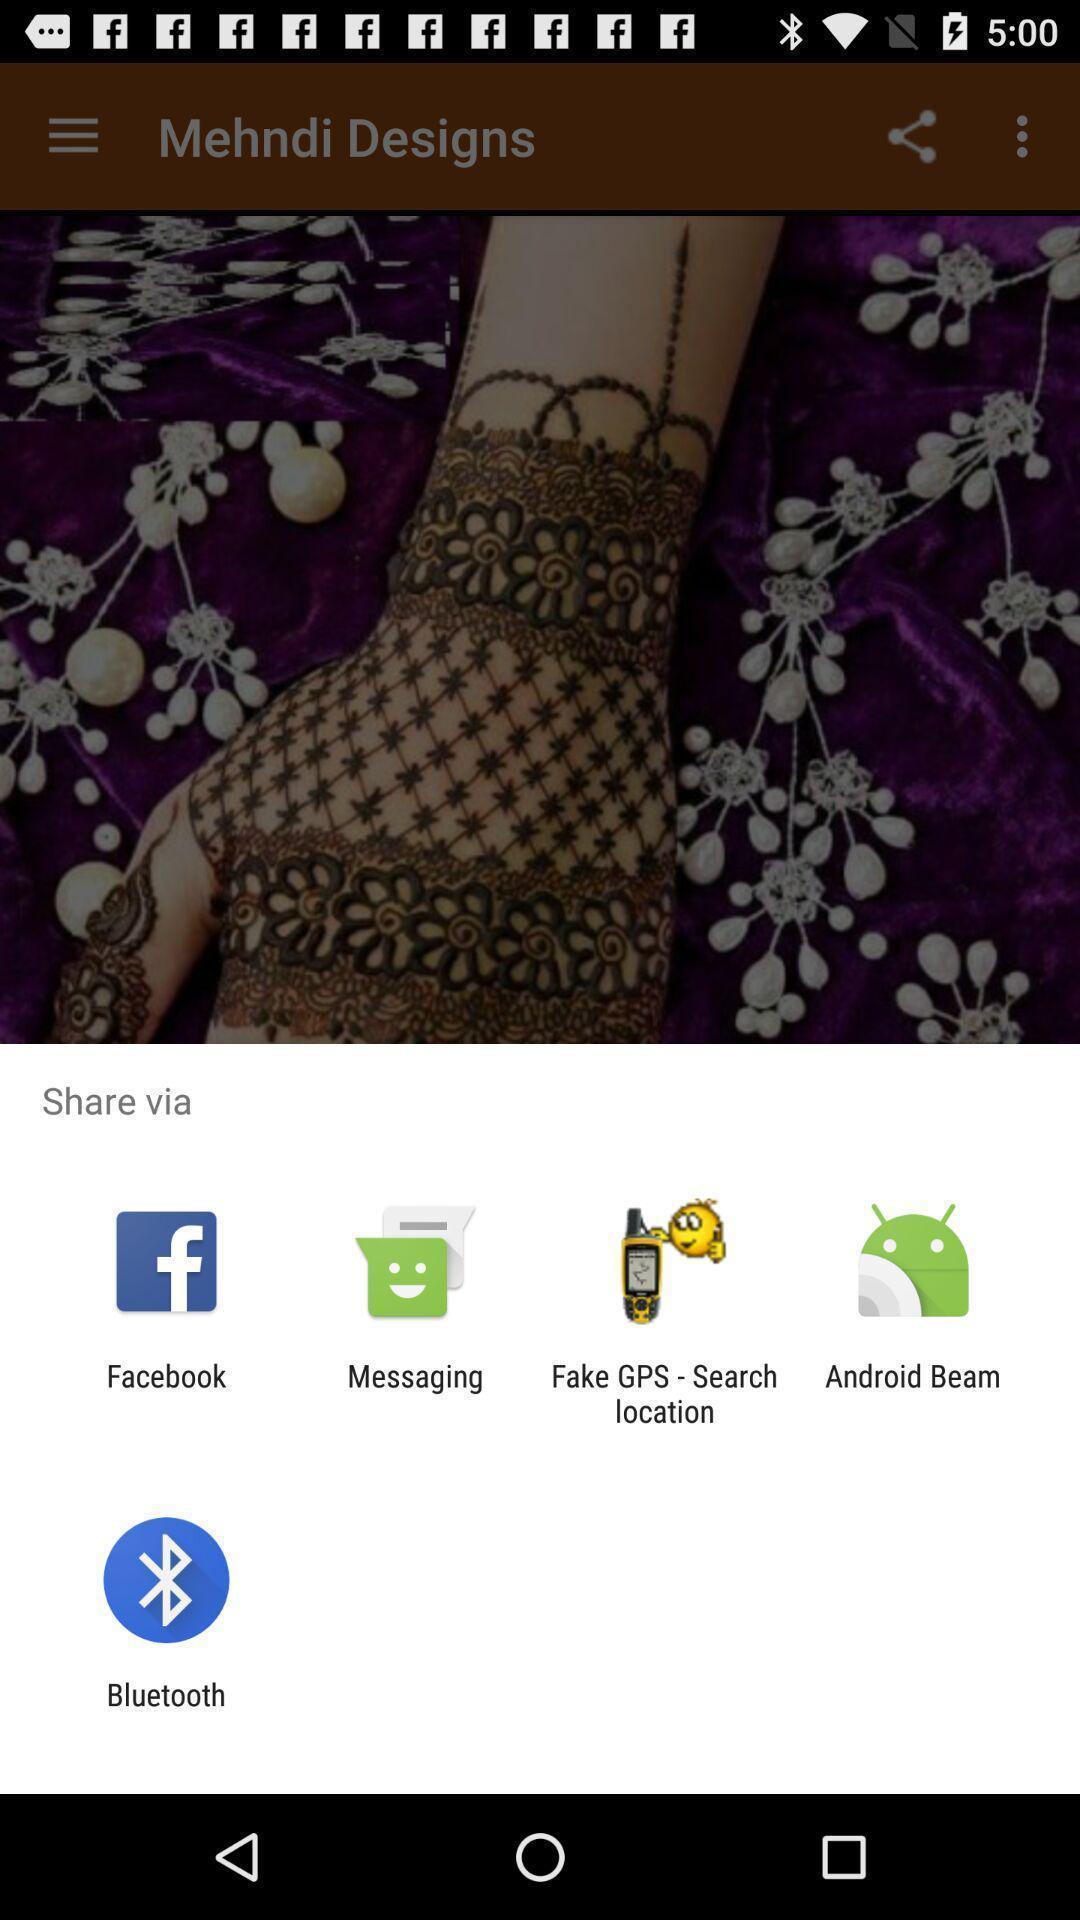Provide a detailed account of this screenshot. Pop-up showing the various image sharing apps. 